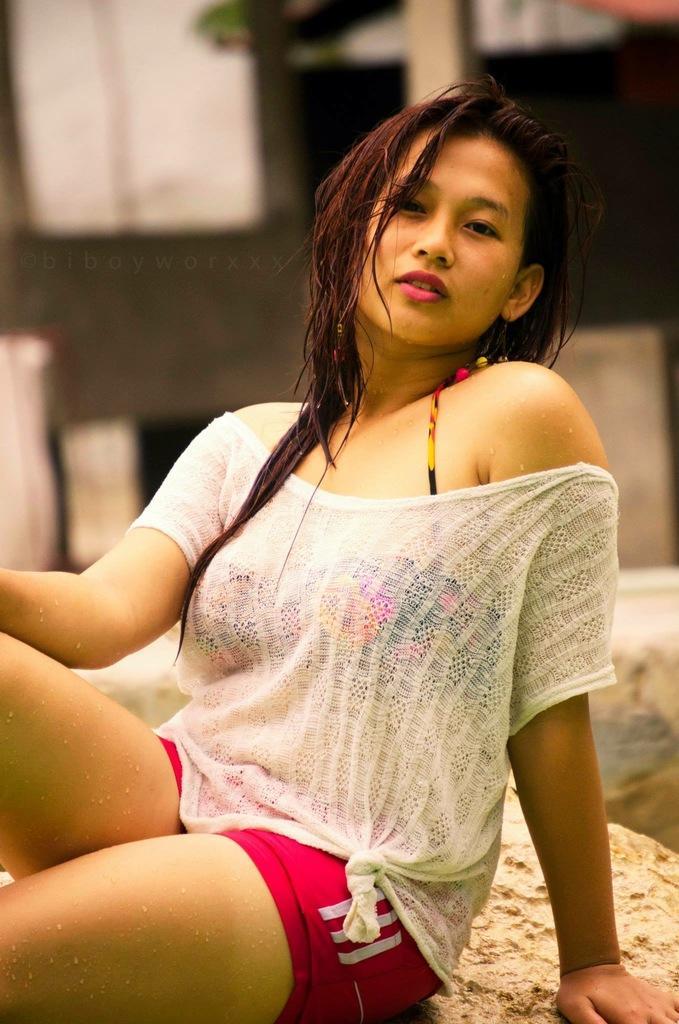How would you summarize this image in a sentence or two? In this image I can see a woman wearing white and red color dress is sitting on a brown colored surface. In the background I can see a pole and the wall which is white and black in color. 